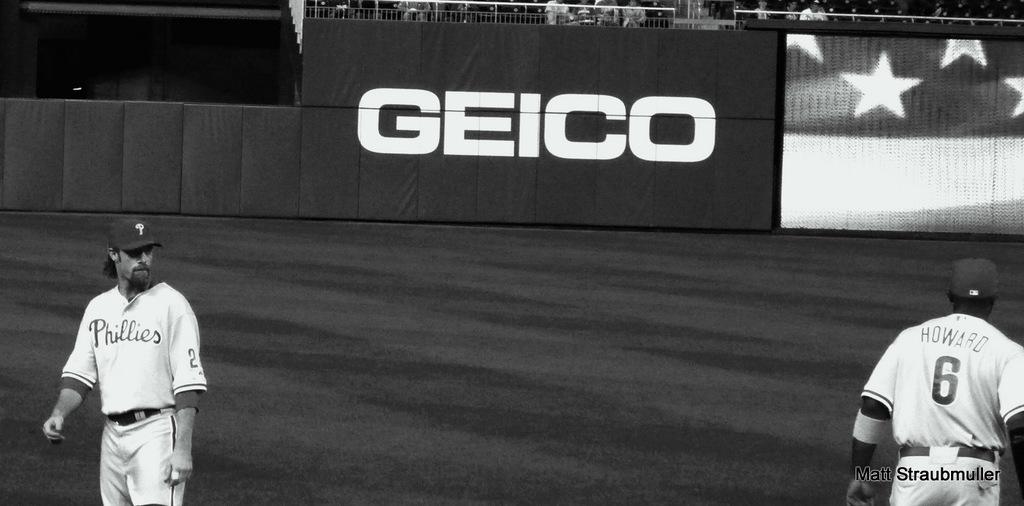Which insurance company sponsors the baseball team?
Keep it short and to the point. Geico. 